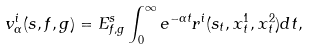<formula> <loc_0><loc_0><loc_500><loc_500>v _ { \alpha } ^ { i } ( s , f , g ) = E _ { f , g } ^ { s } \int _ { 0 } ^ { \infty } e ^ { - \alpha t } r ^ { i } ( s _ { t } , x _ { t } ^ { 1 } , x _ { t } ^ { 2 } ) d t ,</formula> 